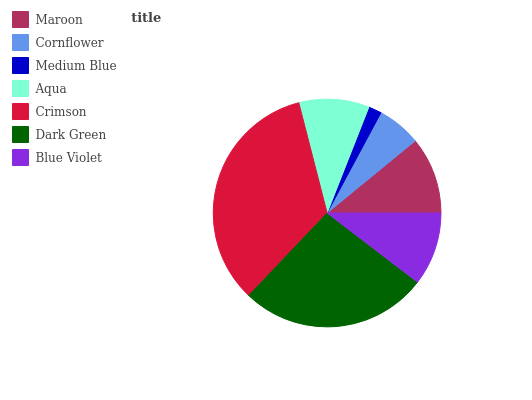Is Medium Blue the minimum?
Answer yes or no. Yes. Is Crimson the maximum?
Answer yes or no. Yes. Is Cornflower the minimum?
Answer yes or no. No. Is Cornflower the maximum?
Answer yes or no. No. Is Maroon greater than Cornflower?
Answer yes or no. Yes. Is Cornflower less than Maroon?
Answer yes or no. Yes. Is Cornflower greater than Maroon?
Answer yes or no. No. Is Maroon less than Cornflower?
Answer yes or no. No. Is Blue Violet the high median?
Answer yes or no. Yes. Is Blue Violet the low median?
Answer yes or no. Yes. Is Medium Blue the high median?
Answer yes or no. No. Is Maroon the low median?
Answer yes or no. No. 